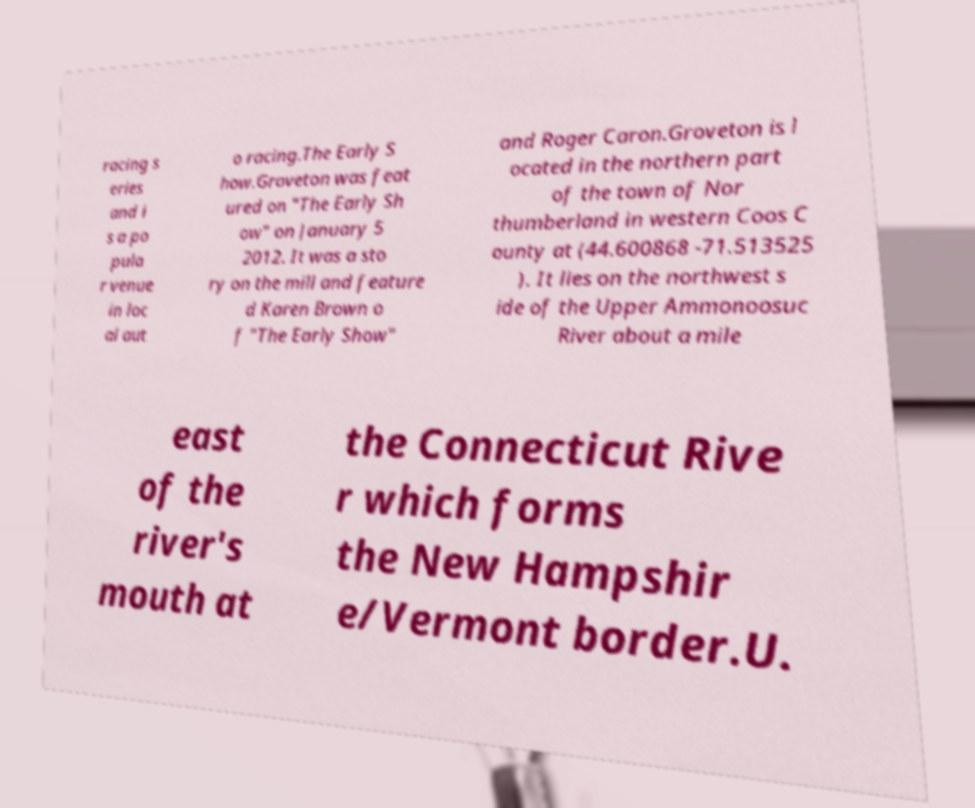Could you extract and type out the text from this image? racing s eries and i s a po pula r venue in loc al aut o racing.The Early S how.Groveton was feat ured on "The Early Sh ow" on January 5 2012. It was a sto ry on the mill and feature d Karen Brown o f "The Early Show" and Roger Caron.Groveton is l ocated in the northern part of the town of Nor thumberland in western Coos C ounty at (44.600868 -71.513525 ). It lies on the northwest s ide of the Upper Ammonoosuc River about a mile east of the river's mouth at the Connecticut Rive r which forms the New Hampshir e/Vermont border.U. 